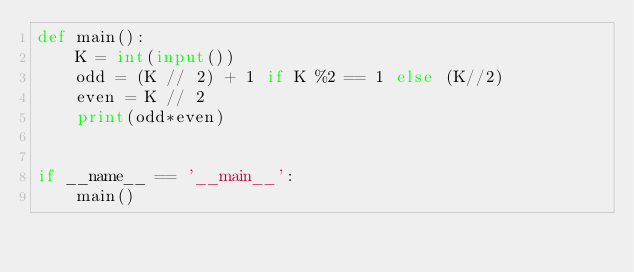<code> <loc_0><loc_0><loc_500><loc_500><_Python_>def main():
	K = int(input())
	odd = (K // 2) + 1 if K %2 == 1 else (K//2)
	even = K // 2
	print(odd*even)


if __name__ == '__main__':
    main()</code> 